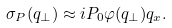Convert formula to latex. <formula><loc_0><loc_0><loc_500><loc_500>\sigma _ { P } ( q _ { \perp } ) \approx i P _ { 0 } \varphi ( q _ { \perp } ) q _ { x } .</formula> 